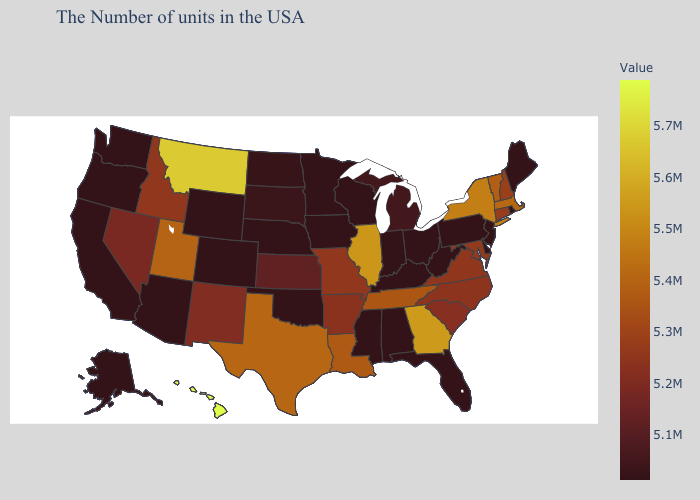Does New Hampshire have the lowest value in the Northeast?
Quick response, please. No. Does Hawaii have the highest value in the USA?
Keep it brief. Yes. Which states have the lowest value in the MidWest?
Short answer required. Ohio, Indiana, Wisconsin, Minnesota, Iowa, Nebraska. Does Hawaii have the highest value in the USA?
Quick response, please. Yes. Which states hav the highest value in the South?
Concise answer only. Georgia. Among the states that border New Mexico , does Utah have the lowest value?
Answer briefly. No. 